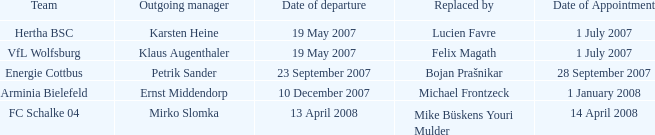When is the appointment set for outgoing manager petrik sander? 28 September 2007. 